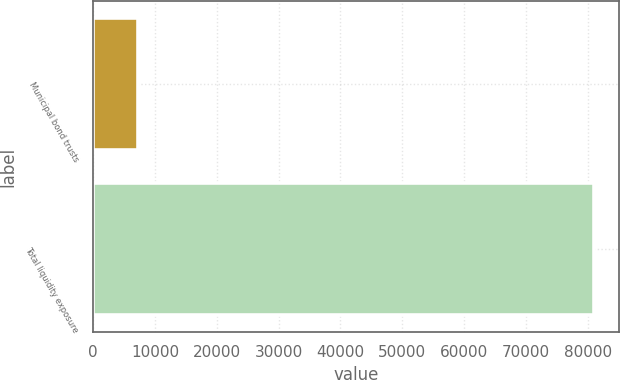Convert chart. <chart><loc_0><loc_0><loc_500><loc_500><bar_chart><fcel>Municipal bond trusts<fcel>Total liquidity exposure<nl><fcel>7189<fcel>80981<nl></chart> 